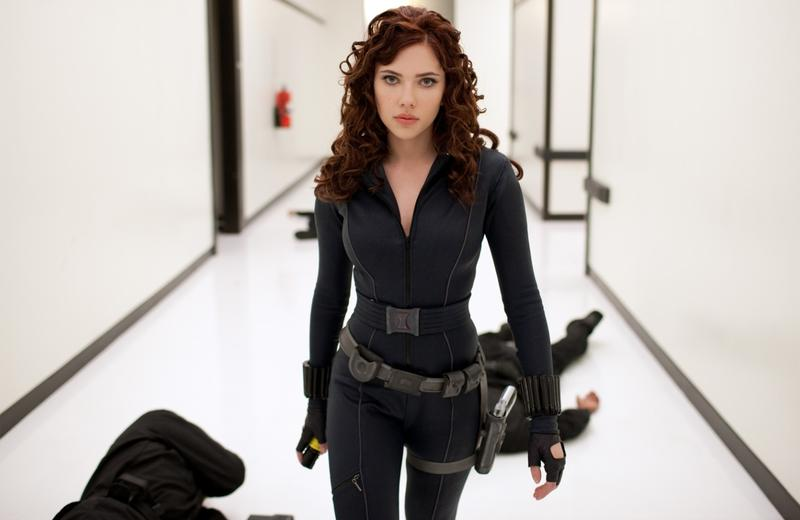Can you explore the role of her hairstyle and overall appearance in shaping viewer’s perception of the character? Her curly hair, which flows naturally, softens her warrior persona and introduces a feminine element that contrasts sharply with her combat attire and the harsh setting. This juxtaposition enhances her multidimensional character - strong yet accessible, fierce yet empathetic. It invites the audience to connect with her not only as a fighter but also as a relatable individual. 